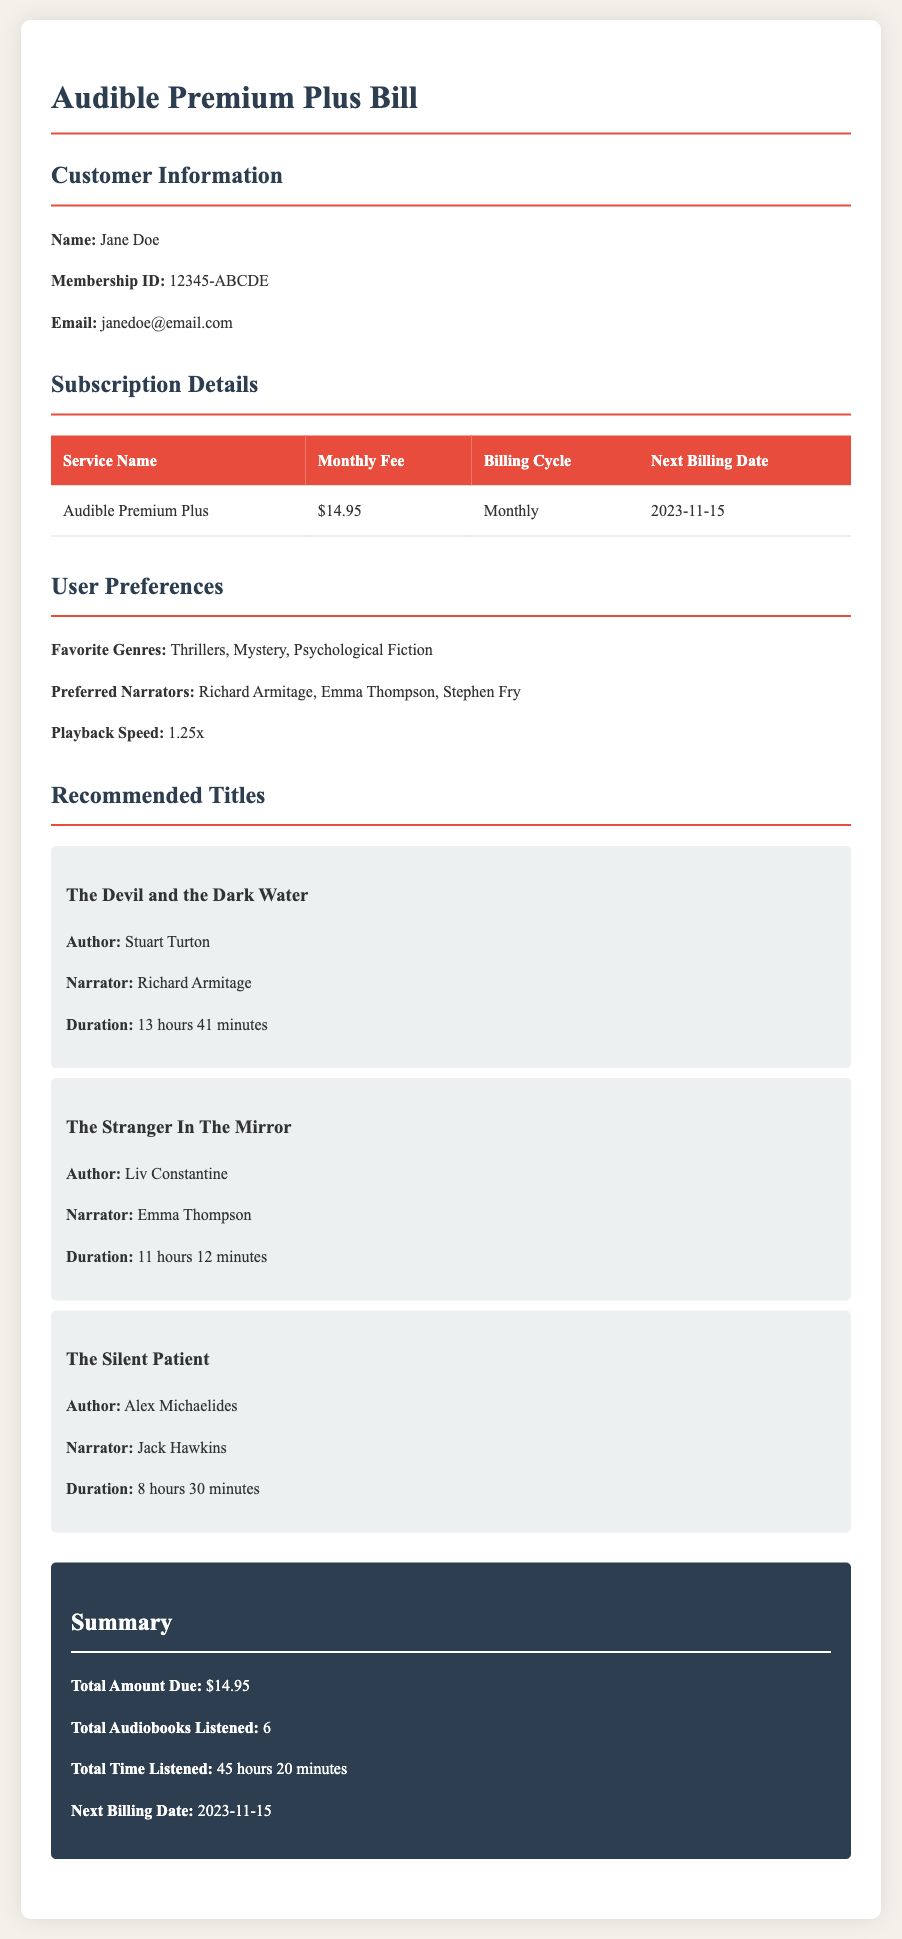What is the monthly fee for the Audible Premium Plus service? The monthly fee is stated in the subscription details section, which is $14.95.
Answer: $14.95 When is the next billing date? The next billing date is mentioned in the subscription details, which is 2023-11-15.
Answer: 2023-11-15 What are Jane Doe's favorite genres? The user preferences section lists Jane Doe's favorite genres as Thrillers, Mystery, Psychological Fiction.
Answer: Thrillers, Mystery, Psychological Fiction Who narrated "The Devil and the Dark Water"? The narrator of "The Devil and the Dark Water" is mentioned alongside the book recommendation, which is Richard Armitage.
Answer: Richard Armitage How many audiobooks has Jane Doe listened to in total? The total audiobooks listened is summarized at the end, which is 6.
Answer: 6 What is the total time listened by Jane Doe? The total time listened is given in the summary, which is 45 hours 20 minutes.
Answer: 45 hours 20 minutes What playback speed does Jane Doe prefer? The preferred playback speed is mentioned in the user preferences section, which is 1.25x.
Answer: 1.25x Which author wrote "The Silent Patient"? The author of "The Silent Patient" is provided in the recommendations section, which is Alex Michaelides.
Answer: Alex Michaelides What color is the summary background? The background color of the summary section is described in the CSS styles, which is #2c3e50 (dark).
Answer: #2c3e50 